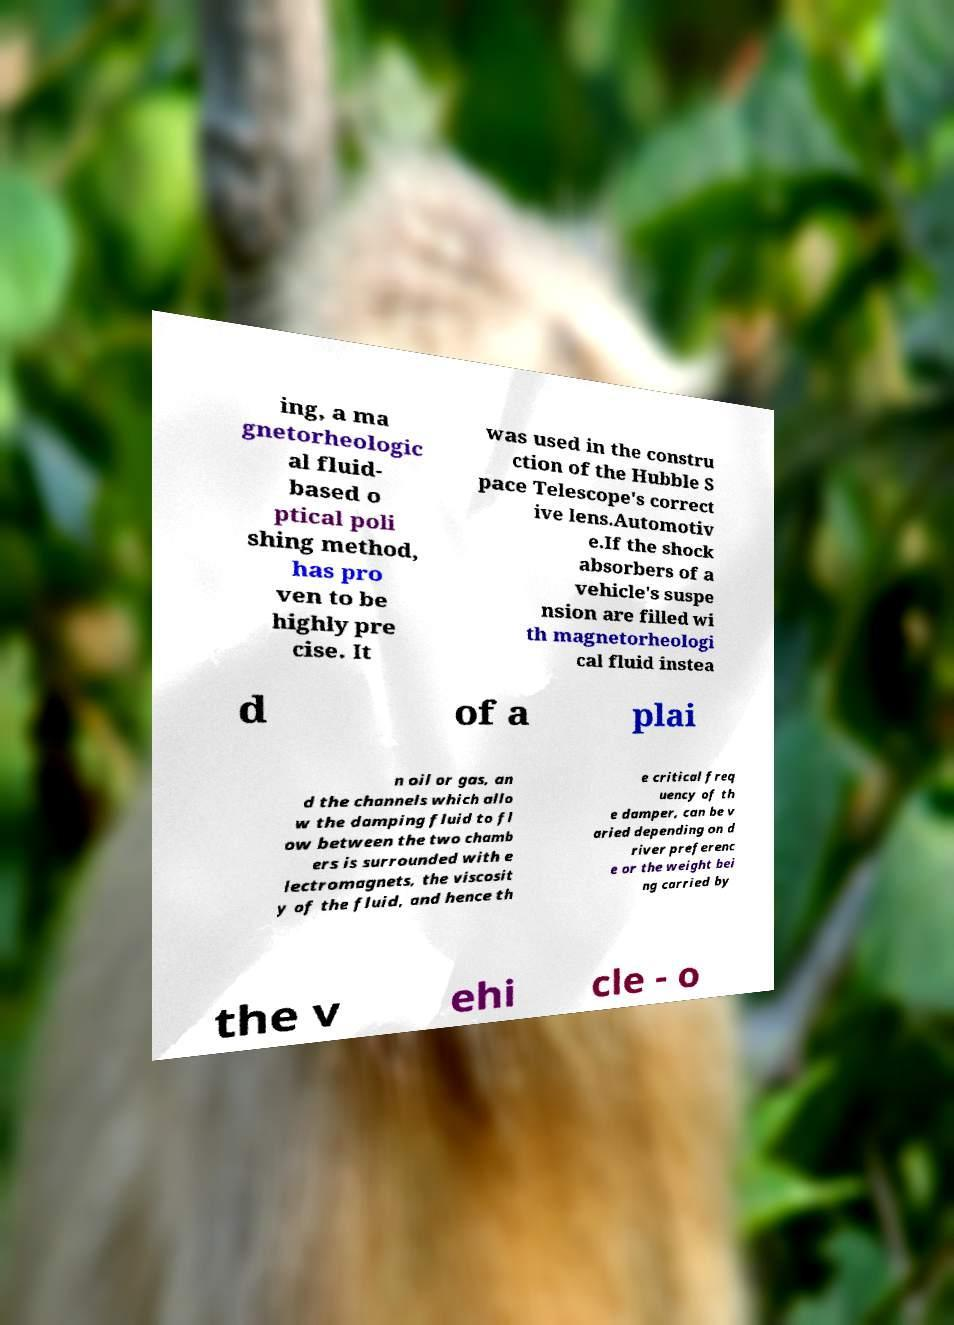Please read and relay the text visible in this image. What does it say? ing, a ma gnetorheologic al fluid- based o ptical poli shing method, has pro ven to be highly pre cise. It was used in the constru ction of the Hubble S pace Telescope's correct ive lens.Automotiv e.If the shock absorbers of a vehicle's suspe nsion are filled wi th magnetorheologi cal fluid instea d of a plai n oil or gas, an d the channels which allo w the damping fluid to fl ow between the two chamb ers is surrounded with e lectromagnets, the viscosit y of the fluid, and hence th e critical freq uency of th e damper, can be v aried depending on d river preferenc e or the weight bei ng carried by the v ehi cle - o 